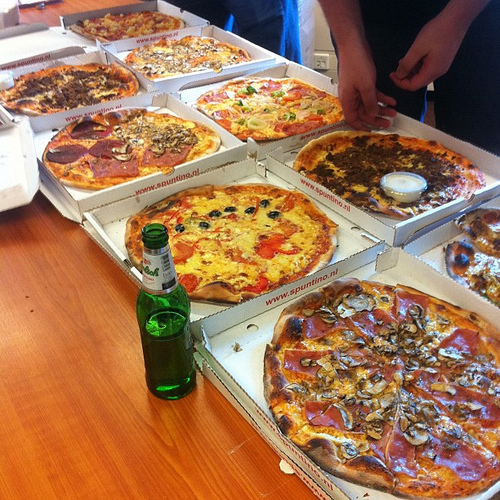Do you see a pizza or a fork there? Yes, I see a pizza. 